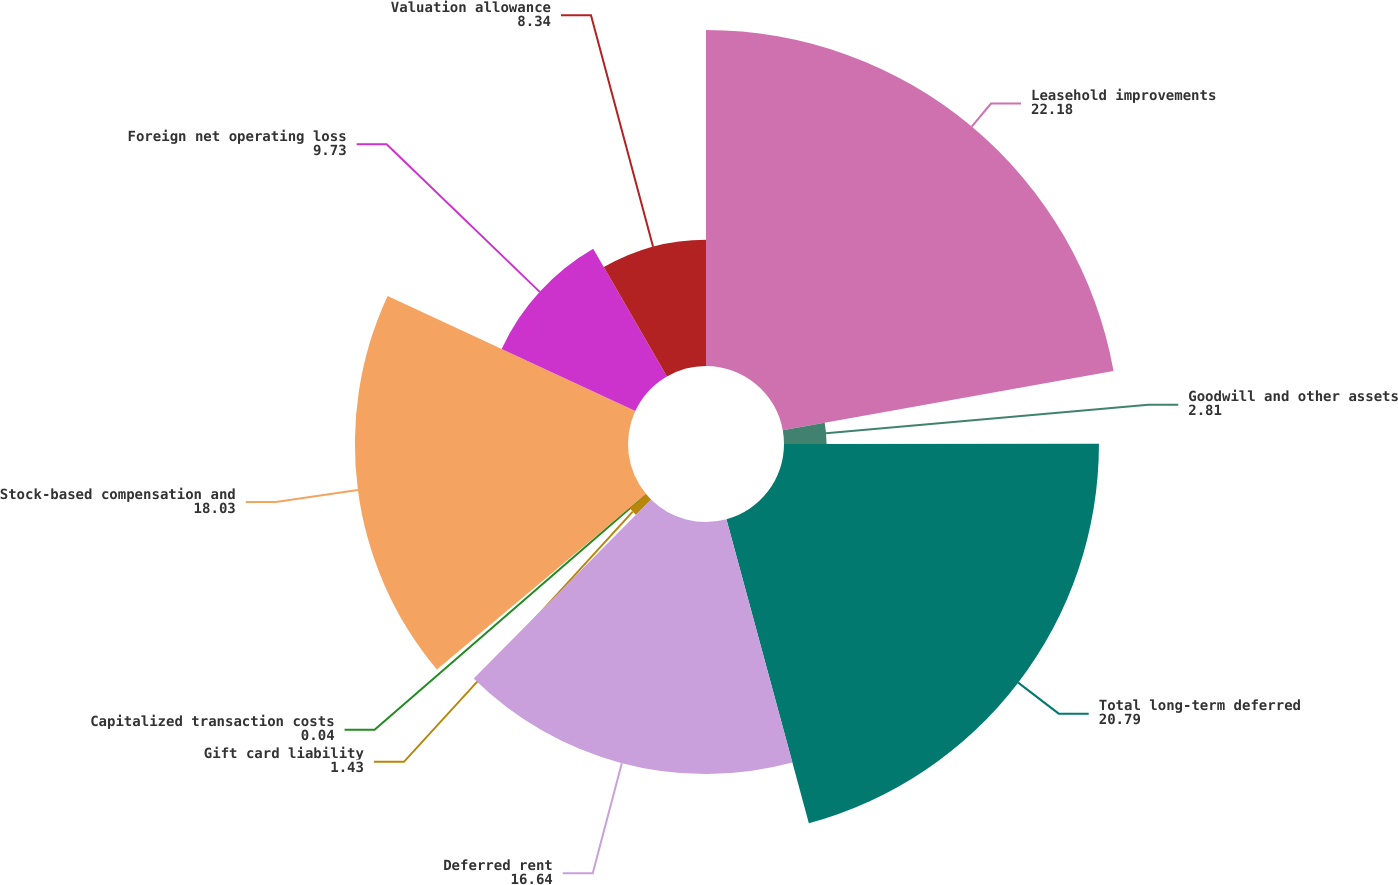Convert chart. <chart><loc_0><loc_0><loc_500><loc_500><pie_chart><fcel>Leasehold improvements<fcel>Goodwill and other assets<fcel>Total long-term deferred<fcel>Deferred rent<fcel>Gift card liability<fcel>Capitalized transaction costs<fcel>Stock-based compensation and<fcel>Foreign net operating loss<fcel>Valuation allowance<nl><fcel>22.18%<fcel>2.81%<fcel>20.79%<fcel>16.64%<fcel>1.43%<fcel>0.04%<fcel>18.03%<fcel>9.73%<fcel>8.34%<nl></chart> 